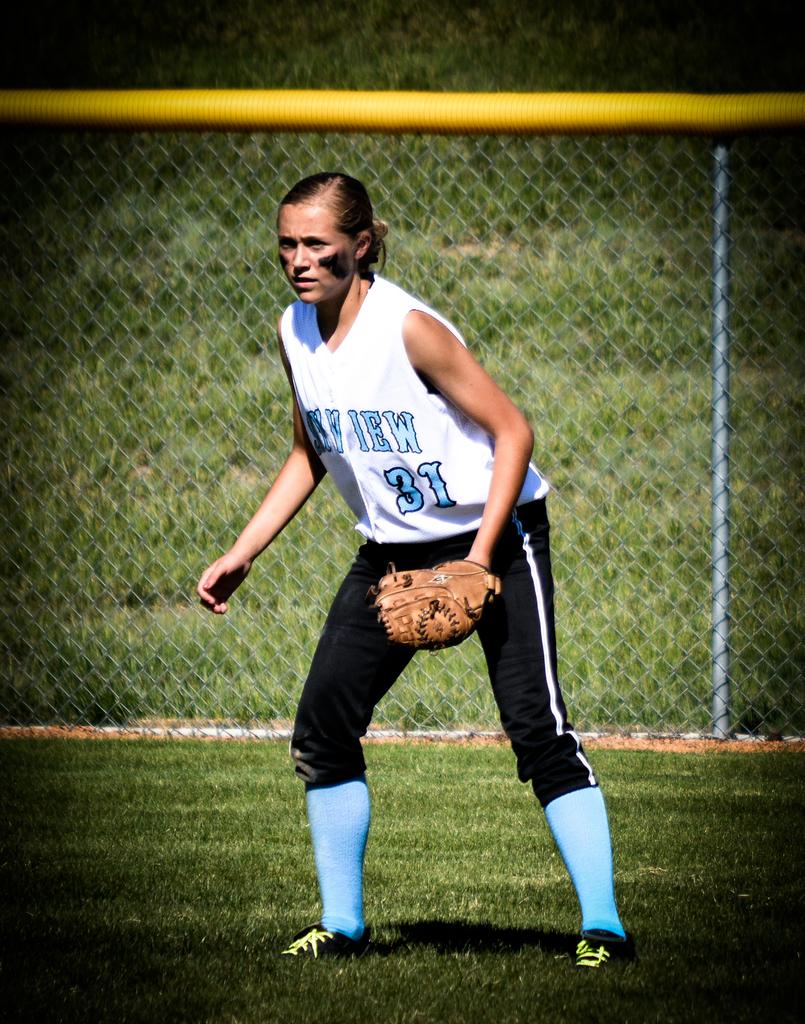What number is the player on her team?
Keep it short and to the point. 31. What number is on the shirt?
Make the answer very short. 31. 